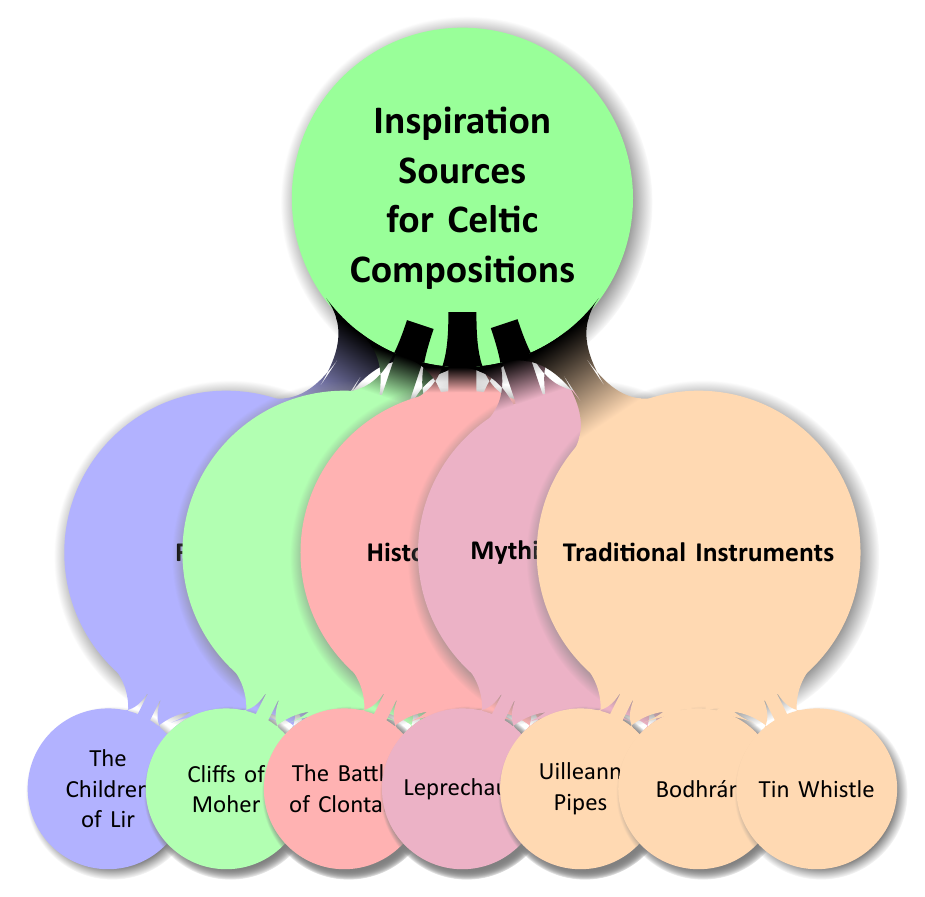What are the two main categories of inspiration sources represented in the mind map? The mind map displays five main categories: Folktales, Nature, Historical Events, Mythical Creatures, and Traditional Instruments. Among these, "Folktales" and "Nature" are two specific categories being asked about.
Answer: Folktales, Nature How many folktales are listed in the diagram? The category of Folktales has three specific instances under it: "The Children of Lir," "The Salmon of Knowledge," and "The Cattle Raid of Cooley." Counting these gives us the total.
Answer: 3 Which mythical creature is known as a trickster fairy? The category of Mythical Creatures includes "Leprechauns," which are specifically described as trickster fairies. Therefore, identifying the trickster fairy leads directly to this answer.
Answer: Leprechauns What scenic location is noted for having majestic sea cliffs? The "Cliffs of Moher" is mentioned under the Nature category as a "Majestic sea cliffs on the western coast of Ireland." Thus, the answer is based on the information directly connected to that node in the diagram.
Answer: Cliffs of Moher Which historical event is associated with a pivotal battle in 1014? In the Historical Events section, "The Battle of Clontarf" is noted as a pivotal battle that took place in 1014. The specific mention of the date is what confirms the answer.
Answer: The Battle of Clontarf How many traditional instruments are listed in the mind map? The Traditional Instruments category comprises three listed instruments: "Uilleann Pipes," "Bodhrán," and "Tin Whistle." By counting these entries, we can derive the answer.
Answer: 3 Which tale features a magical salmon that grants wisdom? "The Salmon of Knowledge" is explicitly mentioned in the Folktales section as the one that grants wisdom, making it the correct answer based on this specific information.
Answer: The Salmon of Knowledge What term is used for shape-shifting spirits in the mind map? Under the Mythical Creatures category, "Púcas" are identified as shape-shifting spirits. The unique term used here allows for a direct identification from the diagram.
Answer: Púcas 